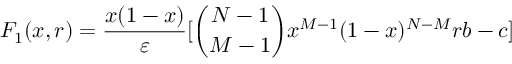Convert formula to latex. <formula><loc_0><loc_0><loc_500><loc_500>F _ { 1 } ( x , r ) = \frac { x ( 1 - x ) } { \varepsilon } [ \binom { N - 1 } { M - 1 } x ^ { M - 1 } ( 1 - x ) ^ { N - M } r b - c ]</formula> 